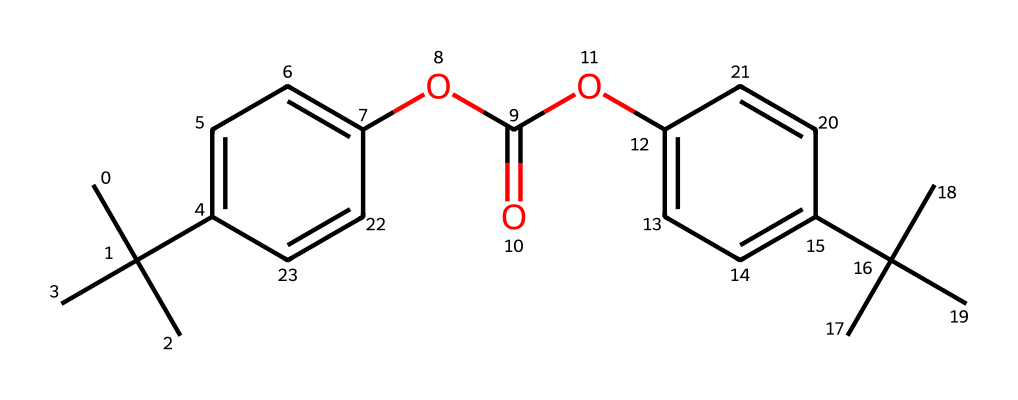What is the molecular formula of this polymer? The polymer's SMILES representation indicates that it is made up of various carbon (C), hydrogen (H), and oxygen (O) atoms. By analyzing the structure, we can deduce the total counts of each atom. Here, we find that there are 28 carbon, 30 hydrogen, and 6 oxygen atoms.
Answer: C28H30O6 How many aromatic rings are present in the structure? Upon inspecting the SMILES representation, we can see that there are two distinct sets of cyclic (ring) structures that exhibit aromatic properties. Each set of phenyl groups is characterized by alternating single and double bonds, indicating aromaticity. Hence, there are two aromatic rings in total.
Answer: 2 What functional groups are detected in this polymer? Looking closely at the SMILES representation, we can identify an ester (-COO-) group due to the presence of carbonyl (C=O) adjacent to an ether (-O-) bond. Additionally, there is a methoxy group (-OCH3) associated with one of the aromatic rings. These distinct features inform us about the functional groups present.
Answer: ester and methoxy What type of polymer is indicated by this structure? The structure exhibits a chain of repeating units with both aromatic and aliphatic elements, characteristic of thermoplastic polymers. Since polycarbonate is a specific type of thermoplastic polymer, we can classify it accordingly based on these features.
Answer: polycarbonate What is the significance of the bulky side groups in the polymer structure? The structure includes significant bulky side groups (intended from branching at the carbon atoms), which suggest that they enhance the impact resistance and durability of the sunglasses made from this polymer. This is critical in added performance and aesthetic properties.
Answer: impact resistance 